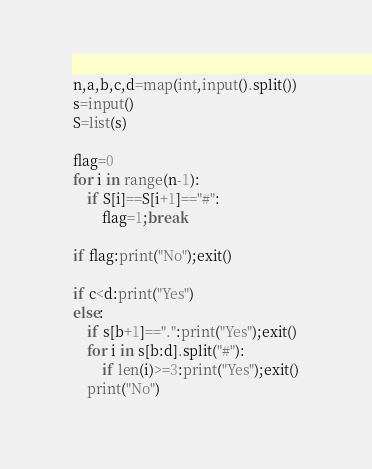Convert code to text. <code><loc_0><loc_0><loc_500><loc_500><_Python_>n,a,b,c,d=map(int,input().split())
s=input()
S=list(s)

flag=0
for i in range(n-1):
    if S[i]==S[i+1]=="#":
        flag=1;break

if flag:print("No");exit()

if c<d:print("Yes")
else:
    if s[b+1]==".":print("Yes");exit()
    for i in s[b:d].split("#"):
        if len(i)>=3:print("Yes");exit()
    print("No")</code> 